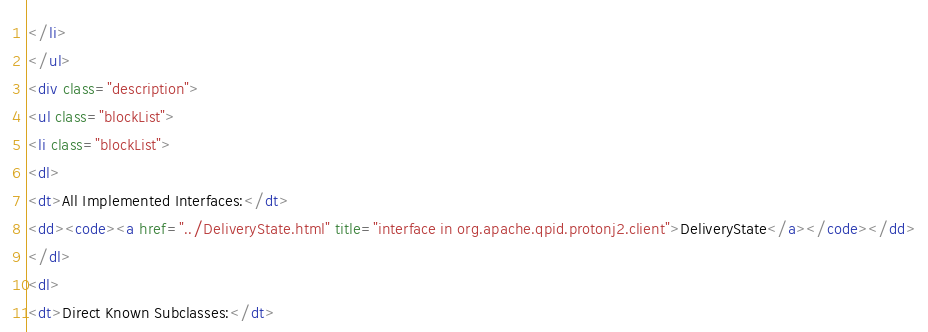Convert code to text. <code><loc_0><loc_0><loc_500><loc_500><_HTML_></li>
</ul>
<div class="description">
<ul class="blockList">
<li class="blockList">
<dl>
<dt>All Implemented Interfaces:</dt>
<dd><code><a href="../DeliveryState.html" title="interface in org.apache.qpid.protonj2.client">DeliveryState</a></code></dd>
</dl>
<dl>
<dt>Direct Known Subclasses:</dt></code> 